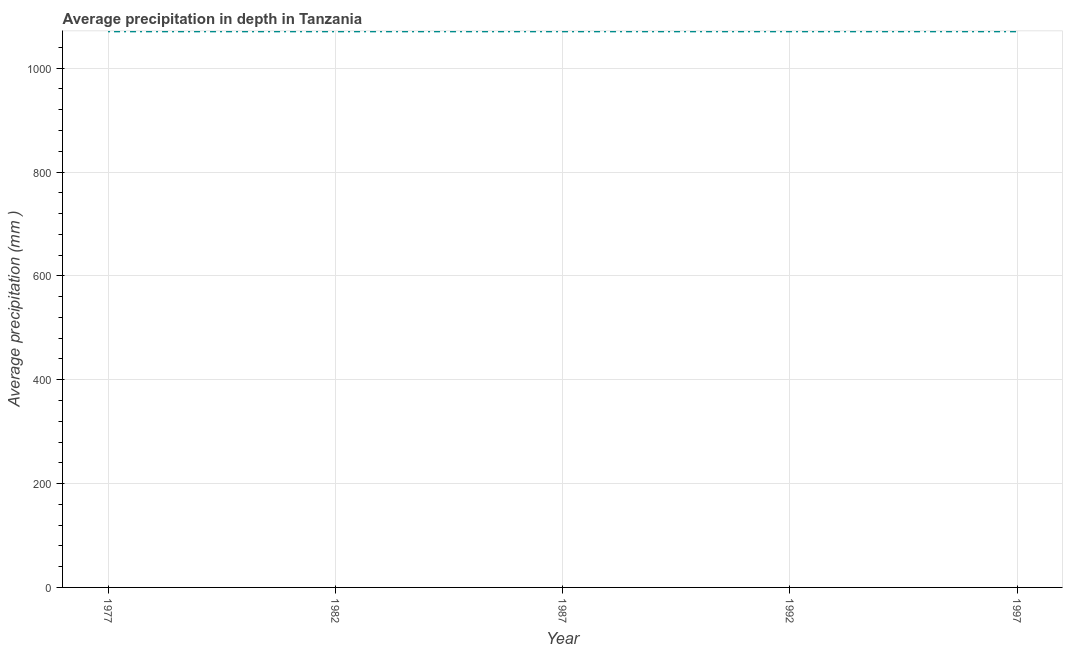What is the average precipitation in depth in 1982?
Your answer should be compact. 1071. Across all years, what is the maximum average precipitation in depth?
Make the answer very short. 1071. Across all years, what is the minimum average precipitation in depth?
Your answer should be compact. 1071. In which year was the average precipitation in depth maximum?
Offer a terse response. 1977. What is the sum of the average precipitation in depth?
Make the answer very short. 5355. What is the average average precipitation in depth per year?
Your response must be concise. 1071. What is the median average precipitation in depth?
Provide a succinct answer. 1071. Is the difference between the average precipitation in depth in 1982 and 1997 greater than the difference between any two years?
Your response must be concise. Yes. What is the difference between the highest and the second highest average precipitation in depth?
Your answer should be very brief. 0. In how many years, is the average precipitation in depth greater than the average average precipitation in depth taken over all years?
Make the answer very short. 0. Does the average precipitation in depth monotonically increase over the years?
Your answer should be very brief. No. How many years are there in the graph?
Offer a very short reply. 5. What is the title of the graph?
Ensure brevity in your answer.  Average precipitation in depth in Tanzania. What is the label or title of the X-axis?
Provide a succinct answer. Year. What is the label or title of the Y-axis?
Ensure brevity in your answer.  Average precipitation (mm ). What is the Average precipitation (mm ) of 1977?
Give a very brief answer. 1071. What is the Average precipitation (mm ) of 1982?
Keep it short and to the point. 1071. What is the Average precipitation (mm ) in 1987?
Make the answer very short. 1071. What is the Average precipitation (mm ) of 1992?
Provide a succinct answer. 1071. What is the Average precipitation (mm ) in 1997?
Keep it short and to the point. 1071. What is the difference between the Average precipitation (mm ) in 1977 and 1992?
Keep it short and to the point. 0. What is the difference between the Average precipitation (mm ) in 1977 and 1997?
Ensure brevity in your answer.  0. What is the difference between the Average precipitation (mm ) in 1992 and 1997?
Keep it short and to the point. 0. What is the ratio of the Average precipitation (mm ) in 1977 to that in 1987?
Ensure brevity in your answer.  1. What is the ratio of the Average precipitation (mm ) in 1977 to that in 1992?
Your answer should be very brief. 1. What is the ratio of the Average precipitation (mm ) in 1982 to that in 1987?
Provide a short and direct response. 1. What is the ratio of the Average precipitation (mm ) in 1982 to that in 1997?
Offer a very short reply. 1. 